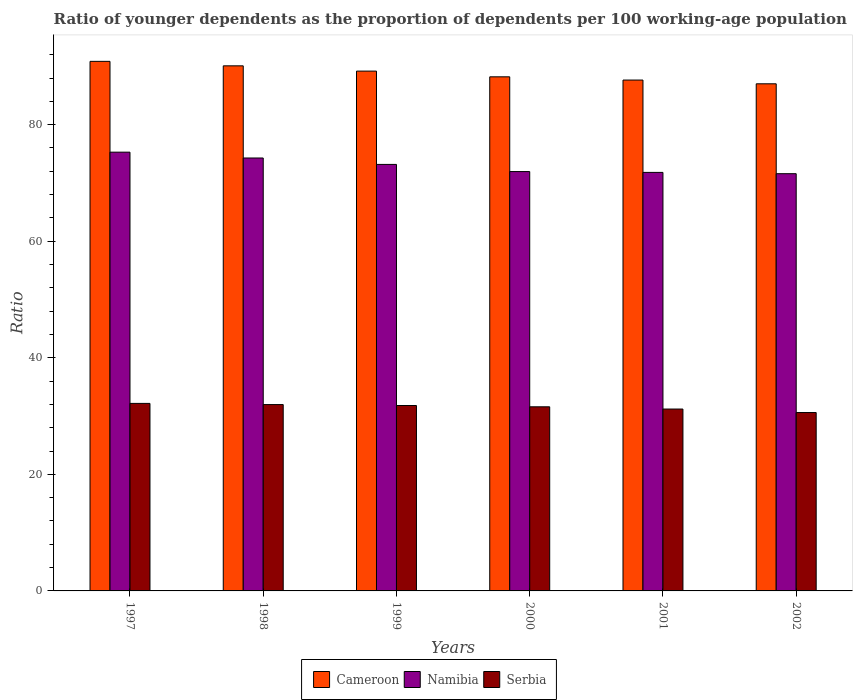How many different coloured bars are there?
Provide a succinct answer. 3. Are the number of bars per tick equal to the number of legend labels?
Your answer should be very brief. Yes. How many bars are there on the 4th tick from the left?
Keep it short and to the point. 3. How many bars are there on the 5th tick from the right?
Provide a succinct answer. 3. In how many cases, is the number of bars for a given year not equal to the number of legend labels?
Your answer should be very brief. 0. What is the age dependency ratio(young) in Cameroon in 2001?
Your answer should be very brief. 87.65. Across all years, what is the maximum age dependency ratio(young) in Namibia?
Offer a terse response. 75.28. Across all years, what is the minimum age dependency ratio(young) in Cameroon?
Make the answer very short. 87. In which year was the age dependency ratio(young) in Namibia minimum?
Your response must be concise. 2002. What is the total age dependency ratio(young) in Serbia in the graph?
Keep it short and to the point. 189.35. What is the difference between the age dependency ratio(young) in Serbia in 1999 and that in 2000?
Your answer should be very brief. 0.22. What is the difference between the age dependency ratio(young) in Namibia in 1998 and the age dependency ratio(young) in Serbia in 1999?
Provide a short and direct response. 42.47. What is the average age dependency ratio(young) in Serbia per year?
Offer a terse response. 31.56. In the year 2002, what is the difference between the age dependency ratio(young) in Namibia and age dependency ratio(young) in Cameroon?
Your response must be concise. -15.42. What is the ratio of the age dependency ratio(young) in Serbia in 1998 to that in 2002?
Give a very brief answer. 1.04. Is the age dependency ratio(young) in Cameroon in 2000 less than that in 2002?
Your response must be concise. No. Is the difference between the age dependency ratio(young) in Namibia in 1998 and 2002 greater than the difference between the age dependency ratio(young) in Cameroon in 1998 and 2002?
Provide a succinct answer. No. What is the difference between the highest and the second highest age dependency ratio(young) in Namibia?
Provide a succinct answer. 1. What is the difference between the highest and the lowest age dependency ratio(young) in Namibia?
Provide a short and direct response. 3.69. Is the sum of the age dependency ratio(young) in Serbia in 1998 and 2002 greater than the maximum age dependency ratio(young) in Namibia across all years?
Your answer should be very brief. No. What does the 3rd bar from the left in 2000 represents?
Provide a short and direct response. Serbia. What does the 1st bar from the right in 2002 represents?
Your answer should be very brief. Serbia. Are the values on the major ticks of Y-axis written in scientific E-notation?
Keep it short and to the point. No. Does the graph contain any zero values?
Your answer should be very brief. No. Where does the legend appear in the graph?
Your response must be concise. Bottom center. How are the legend labels stacked?
Offer a very short reply. Horizontal. What is the title of the graph?
Offer a very short reply. Ratio of younger dependents as the proportion of dependents per 100 working-age population. Does "North America" appear as one of the legend labels in the graph?
Offer a very short reply. No. What is the label or title of the Y-axis?
Provide a short and direct response. Ratio. What is the Ratio of Cameroon in 1997?
Keep it short and to the point. 90.86. What is the Ratio of Namibia in 1997?
Offer a very short reply. 75.28. What is the Ratio of Serbia in 1997?
Provide a short and direct response. 32.17. What is the Ratio of Cameroon in 1998?
Your response must be concise. 90.09. What is the Ratio of Namibia in 1998?
Your answer should be compact. 74.28. What is the Ratio in Serbia in 1998?
Your answer should be very brief. 31.97. What is the Ratio in Cameroon in 1999?
Provide a succinct answer. 89.18. What is the Ratio in Namibia in 1999?
Make the answer very short. 73.18. What is the Ratio in Serbia in 1999?
Keep it short and to the point. 31.81. What is the Ratio in Cameroon in 2000?
Keep it short and to the point. 88.2. What is the Ratio of Namibia in 2000?
Offer a very short reply. 71.95. What is the Ratio in Serbia in 2000?
Provide a short and direct response. 31.59. What is the Ratio of Cameroon in 2001?
Keep it short and to the point. 87.65. What is the Ratio of Namibia in 2001?
Your response must be concise. 71.8. What is the Ratio in Serbia in 2001?
Offer a very short reply. 31.2. What is the Ratio of Cameroon in 2002?
Keep it short and to the point. 87. What is the Ratio in Namibia in 2002?
Give a very brief answer. 71.58. What is the Ratio of Serbia in 2002?
Provide a succinct answer. 30.6. Across all years, what is the maximum Ratio of Cameroon?
Offer a very short reply. 90.86. Across all years, what is the maximum Ratio in Namibia?
Your answer should be compact. 75.28. Across all years, what is the maximum Ratio in Serbia?
Ensure brevity in your answer.  32.17. Across all years, what is the minimum Ratio of Cameroon?
Provide a short and direct response. 87. Across all years, what is the minimum Ratio in Namibia?
Make the answer very short. 71.58. Across all years, what is the minimum Ratio in Serbia?
Offer a very short reply. 30.6. What is the total Ratio of Cameroon in the graph?
Give a very brief answer. 532.98. What is the total Ratio of Namibia in the graph?
Your response must be concise. 438.06. What is the total Ratio in Serbia in the graph?
Offer a very short reply. 189.35. What is the difference between the Ratio of Cameroon in 1997 and that in 1998?
Your answer should be compact. 0.77. What is the difference between the Ratio of Serbia in 1997 and that in 1998?
Your response must be concise. 0.2. What is the difference between the Ratio in Cameroon in 1997 and that in 1999?
Ensure brevity in your answer.  1.67. What is the difference between the Ratio in Namibia in 1997 and that in 1999?
Your answer should be compact. 2.1. What is the difference between the Ratio of Serbia in 1997 and that in 1999?
Your answer should be very brief. 0.36. What is the difference between the Ratio in Cameroon in 1997 and that in 2000?
Keep it short and to the point. 2.65. What is the difference between the Ratio in Namibia in 1997 and that in 2000?
Provide a short and direct response. 3.33. What is the difference between the Ratio of Serbia in 1997 and that in 2000?
Give a very brief answer. 0.58. What is the difference between the Ratio of Cameroon in 1997 and that in 2001?
Ensure brevity in your answer.  3.21. What is the difference between the Ratio of Namibia in 1997 and that in 2001?
Your answer should be very brief. 3.47. What is the difference between the Ratio in Serbia in 1997 and that in 2001?
Keep it short and to the point. 0.97. What is the difference between the Ratio in Cameroon in 1997 and that in 2002?
Offer a terse response. 3.85. What is the difference between the Ratio in Namibia in 1997 and that in 2002?
Keep it short and to the point. 3.69. What is the difference between the Ratio in Serbia in 1997 and that in 2002?
Your answer should be compact. 1.57. What is the difference between the Ratio of Cameroon in 1998 and that in 1999?
Your answer should be very brief. 0.9. What is the difference between the Ratio in Namibia in 1998 and that in 1999?
Keep it short and to the point. 1.1. What is the difference between the Ratio of Serbia in 1998 and that in 1999?
Keep it short and to the point. 0.16. What is the difference between the Ratio in Cameroon in 1998 and that in 2000?
Your answer should be compact. 1.89. What is the difference between the Ratio of Namibia in 1998 and that in 2000?
Give a very brief answer. 2.33. What is the difference between the Ratio in Serbia in 1998 and that in 2000?
Provide a short and direct response. 0.38. What is the difference between the Ratio in Cameroon in 1998 and that in 2001?
Give a very brief answer. 2.44. What is the difference between the Ratio of Namibia in 1998 and that in 2001?
Your response must be concise. 2.47. What is the difference between the Ratio of Serbia in 1998 and that in 2001?
Ensure brevity in your answer.  0.77. What is the difference between the Ratio of Cameroon in 1998 and that in 2002?
Give a very brief answer. 3.08. What is the difference between the Ratio of Namibia in 1998 and that in 2002?
Ensure brevity in your answer.  2.69. What is the difference between the Ratio of Serbia in 1998 and that in 2002?
Your answer should be compact. 1.37. What is the difference between the Ratio in Cameroon in 1999 and that in 2000?
Provide a succinct answer. 0.98. What is the difference between the Ratio in Namibia in 1999 and that in 2000?
Provide a short and direct response. 1.23. What is the difference between the Ratio in Serbia in 1999 and that in 2000?
Provide a short and direct response. 0.22. What is the difference between the Ratio in Cameroon in 1999 and that in 2001?
Offer a terse response. 1.54. What is the difference between the Ratio of Namibia in 1999 and that in 2001?
Your response must be concise. 1.37. What is the difference between the Ratio of Serbia in 1999 and that in 2001?
Your response must be concise. 0.61. What is the difference between the Ratio in Cameroon in 1999 and that in 2002?
Provide a succinct answer. 2.18. What is the difference between the Ratio of Namibia in 1999 and that in 2002?
Offer a terse response. 1.59. What is the difference between the Ratio in Serbia in 1999 and that in 2002?
Provide a short and direct response. 1.21. What is the difference between the Ratio in Cameroon in 2000 and that in 2001?
Offer a very short reply. 0.55. What is the difference between the Ratio in Namibia in 2000 and that in 2001?
Make the answer very short. 0.14. What is the difference between the Ratio in Serbia in 2000 and that in 2001?
Provide a short and direct response. 0.38. What is the difference between the Ratio of Cameroon in 2000 and that in 2002?
Offer a very short reply. 1.2. What is the difference between the Ratio in Namibia in 2000 and that in 2002?
Offer a terse response. 0.36. What is the difference between the Ratio in Serbia in 2000 and that in 2002?
Keep it short and to the point. 0.98. What is the difference between the Ratio in Cameroon in 2001 and that in 2002?
Provide a succinct answer. 0.64. What is the difference between the Ratio of Namibia in 2001 and that in 2002?
Ensure brevity in your answer.  0.22. What is the difference between the Ratio in Serbia in 2001 and that in 2002?
Keep it short and to the point. 0.6. What is the difference between the Ratio in Cameroon in 1997 and the Ratio in Namibia in 1998?
Provide a short and direct response. 16.58. What is the difference between the Ratio of Cameroon in 1997 and the Ratio of Serbia in 1998?
Ensure brevity in your answer.  58.88. What is the difference between the Ratio in Namibia in 1997 and the Ratio in Serbia in 1998?
Offer a terse response. 43.3. What is the difference between the Ratio of Cameroon in 1997 and the Ratio of Namibia in 1999?
Give a very brief answer. 17.68. What is the difference between the Ratio in Cameroon in 1997 and the Ratio in Serbia in 1999?
Provide a succinct answer. 59.05. What is the difference between the Ratio in Namibia in 1997 and the Ratio in Serbia in 1999?
Give a very brief answer. 43.47. What is the difference between the Ratio in Cameroon in 1997 and the Ratio in Namibia in 2000?
Keep it short and to the point. 18.91. What is the difference between the Ratio in Cameroon in 1997 and the Ratio in Serbia in 2000?
Keep it short and to the point. 59.27. What is the difference between the Ratio in Namibia in 1997 and the Ratio in Serbia in 2000?
Your response must be concise. 43.69. What is the difference between the Ratio of Cameroon in 1997 and the Ratio of Namibia in 2001?
Make the answer very short. 19.05. What is the difference between the Ratio of Cameroon in 1997 and the Ratio of Serbia in 2001?
Your answer should be very brief. 59.65. What is the difference between the Ratio of Namibia in 1997 and the Ratio of Serbia in 2001?
Offer a very short reply. 44.07. What is the difference between the Ratio of Cameroon in 1997 and the Ratio of Namibia in 2002?
Offer a very short reply. 19.27. What is the difference between the Ratio in Cameroon in 1997 and the Ratio in Serbia in 2002?
Your answer should be compact. 60.25. What is the difference between the Ratio in Namibia in 1997 and the Ratio in Serbia in 2002?
Keep it short and to the point. 44.67. What is the difference between the Ratio of Cameroon in 1998 and the Ratio of Namibia in 1999?
Your answer should be very brief. 16.91. What is the difference between the Ratio in Cameroon in 1998 and the Ratio in Serbia in 1999?
Provide a succinct answer. 58.28. What is the difference between the Ratio in Namibia in 1998 and the Ratio in Serbia in 1999?
Offer a terse response. 42.47. What is the difference between the Ratio in Cameroon in 1998 and the Ratio in Namibia in 2000?
Make the answer very short. 18.14. What is the difference between the Ratio of Cameroon in 1998 and the Ratio of Serbia in 2000?
Ensure brevity in your answer.  58.5. What is the difference between the Ratio in Namibia in 1998 and the Ratio in Serbia in 2000?
Give a very brief answer. 42.69. What is the difference between the Ratio of Cameroon in 1998 and the Ratio of Namibia in 2001?
Provide a short and direct response. 18.28. What is the difference between the Ratio in Cameroon in 1998 and the Ratio in Serbia in 2001?
Make the answer very short. 58.88. What is the difference between the Ratio of Namibia in 1998 and the Ratio of Serbia in 2001?
Your answer should be very brief. 43.07. What is the difference between the Ratio in Cameroon in 1998 and the Ratio in Namibia in 2002?
Your answer should be compact. 18.5. What is the difference between the Ratio in Cameroon in 1998 and the Ratio in Serbia in 2002?
Give a very brief answer. 59.48. What is the difference between the Ratio of Namibia in 1998 and the Ratio of Serbia in 2002?
Make the answer very short. 43.67. What is the difference between the Ratio in Cameroon in 1999 and the Ratio in Namibia in 2000?
Your answer should be very brief. 17.24. What is the difference between the Ratio in Cameroon in 1999 and the Ratio in Serbia in 2000?
Your answer should be compact. 57.59. What is the difference between the Ratio in Namibia in 1999 and the Ratio in Serbia in 2000?
Provide a succinct answer. 41.59. What is the difference between the Ratio in Cameroon in 1999 and the Ratio in Namibia in 2001?
Your answer should be compact. 17.38. What is the difference between the Ratio in Cameroon in 1999 and the Ratio in Serbia in 2001?
Offer a terse response. 57.98. What is the difference between the Ratio in Namibia in 1999 and the Ratio in Serbia in 2001?
Your answer should be very brief. 41.97. What is the difference between the Ratio of Cameroon in 1999 and the Ratio of Namibia in 2002?
Offer a terse response. 17.6. What is the difference between the Ratio in Cameroon in 1999 and the Ratio in Serbia in 2002?
Your answer should be very brief. 58.58. What is the difference between the Ratio of Namibia in 1999 and the Ratio of Serbia in 2002?
Give a very brief answer. 42.57. What is the difference between the Ratio of Cameroon in 2000 and the Ratio of Namibia in 2001?
Provide a succinct answer. 16.4. What is the difference between the Ratio in Cameroon in 2000 and the Ratio in Serbia in 2001?
Keep it short and to the point. 57. What is the difference between the Ratio in Namibia in 2000 and the Ratio in Serbia in 2001?
Your response must be concise. 40.74. What is the difference between the Ratio of Cameroon in 2000 and the Ratio of Namibia in 2002?
Offer a terse response. 16.62. What is the difference between the Ratio in Cameroon in 2000 and the Ratio in Serbia in 2002?
Ensure brevity in your answer.  57.6. What is the difference between the Ratio of Namibia in 2000 and the Ratio of Serbia in 2002?
Your answer should be compact. 41.34. What is the difference between the Ratio of Cameroon in 2001 and the Ratio of Namibia in 2002?
Keep it short and to the point. 16.06. What is the difference between the Ratio in Cameroon in 2001 and the Ratio in Serbia in 2002?
Provide a succinct answer. 57.04. What is the difference between the Ratio of Namibia in 2001 and the Ratio of Serbia in 2002?
Make the answer very short. 41.2. What is the average Ratio of Cameroon per year?
Offer a terse response. 88.83. What is the average Ratio in Namibia per year?
Ensure brevity in your answer.  73.01. What is the average Ratio in Serbia per year?
Keep it short and to the point. 31.56. In the year 1997, what is the difference between the Ratio of Cameroon and Ratio of Namibia?
Offer a very short reply. 15.58. In the year 1997, what is the difference between the Ratio of Cameroon and Ratio of Serbia?
Your response must be concise. 58.68. In the year 1997, what is the difference between the Ratio of Namibia and Ratio of Serbia?
Provide a succinct answer. 43.1. In the year 1998, what is the difference between the Ratio of Cameroon and Ratio of Namibia?
Ensure brevity in your answer.  15.81. In the year 1998, what is the difference between the Ratio in Cameroon and Ratio in Serbia?
Ensure brevity in your answer.  58.12. In the year 1998, what is the difference between the Ratio in Namibia and Ratio in Serbia?
Provide a succinct answer. 42.3. In the year 1999, what is the difference between the Ratio of Cameroon and Ratio of Namibia?
Offer a very short reply. 16.01. In the year 1999, what is the difference between the Ratio of Cameroon and Ratio of Serbia?
Your answer should be compact. 57.37. In the year 1999, what is the difference between the Ratio in Namibia and Ratio in Serbia?
Offer a terse response. 41.37. In the year 2000, what is the difference between the Ratio in Cameroon and Ratio in Namibia?
Offer a terse response. 16.26. In the year 2000, what is the difference between the Ratio of Cameroon and Ratio of Serbia?
Your answer should be compact. 56.61. In the year 2000, what is the difference between the Ratio of Namibia and Ratio of Serbia?
Ensure brevity in your answer.  40.36. In the year 2001, what is the difference between the Ratio of Cameroon and Ratio of Namibia?
Your answer should be compact. 15.84. In the year 2001, what is the difference between the Ratio in Cameroon and Ratio in Serbia?
Keep it short and to the point. 56.44. In the year 2001, what is the difference between the Ratio of Namibia and Ratio of Serbia?
Your answer should be very brief. 40.6. In the year 2002, what is the difference between the Ratio in Cameroon and Ratio in Namibia?
Offer a very short reply. 15.42. In the year 2002, what is the difference between the Ratio of Cameroon and Ratio of Serbia?
Offer a very short reply. 56.4. In the year 2002, what is the difference between the Ratio of Namibia and Ratio of Serbia?
Provide a succinct answer. 40.98. What is the ratio of the Ratio in Cameroon in 1997 to that in 1998?
Make the answer very short. 1.01. What is the ratio of the Ratio in Namibia in 1997 to that in 1998?
Give a very brief answer. 1.01. What is the ratio of the Ratio in Cameroon in 1997 to that in 1999?
Provide a short and direct response. 1.02. What is the ratio of the Ratio in Namibia in 1997 to that in 1999?
Keep it short and to the point. 1.03. What is the ratio of the Ratio in Serbia in 1997 to that in 1999?
Offer a very short reply. 1.01. What is the ratio of the Ratio of Cameroon in 1997 to that in 2000?
Keep it short and to the point. 1.03. What is the ratio of the Ratio in Namibia in 1997 to that in 2000?
Ensure brevity in your answer.  1.05. What is the ratio of the Ratio in Serbia in 1997 to that in 2000?
Keep it short and to the point. 1.02. What is the ratio of the Ratio in Cameroon in 1997 to that in 2001?
Your answer should be compact. 1.04. What is the ratio of the Ratio in Namibia in 1997 to that in 2001?
Provide a succinct answer. 1.05. What is the ratio of the Ratio of Serbia in 1997 to that in 2001?
Your answer should be very brief. 1.03. What is the ratio of the Ratio of Cameroon in 1997 to that in 2002?
Your answer should be compact. 1.04. What is the ratio of the Ratio in Namibia in 1997 to that in 2002?
Offer a terse response. 1.05. What is the ratio of the Ratio in Serbia in 1997 to that in 2002?
Your response must be concise. 1.05. What is the ratio of the Ratio in Cameroon in 1998 to that in 1999?
Keep it short and to the point. 1.01. What is the ratio of the Ratio of Namibia in 1998 to that in 1999?
Provide a succinct answer. 1.02. What is the ratio of the Ratio of Cameroon in 1998 to that in 2000?
Your answer should be compact. 1.02. What is the ratio of the Ratio in Namibia in 1998 to that in 2000?
Offer a very short reply. 1.03. What is the ratio of the Ratio of Serbia in 1998 to that in 2000?
Provide a succinct answer. 1.01. What is the ratio of the Ratio in Cameroon in 1998 to that in 2001?
Your answer should be very brief. 1.03. What is the ratio of the Ratio of Namibia in 1998 to that in 2001?
Offer a very short reply. 1.03. What is the ratio of the Ratio in Serbia in 1998 to that in 2001?
Offer a terse response. 1.02. What is the ratio of the Ratio of Cameroon in 1998 to that in 2002?
Give a very brief answer. 1.04. What is the ratio of the Ratio of Namibia in 1998 to that in 2002?
Keep it short and to the point. 1.04. What is the ratio of the Ratio of Serbia in 1998 to that in 2002?
Keep it short and to the point. 1.04. What is the ratio of the Ratio in Cameroon in 1999 to that in 2000?
Ensure brevity in your answer.  1.01. What is the ratio of the Ratio in Namibia in 1999 to that in 2000?
Make the answer very short. 1.02. What is the ratio of the Ratio in Serbia in 1999 to that in 2000?
Keep it short and to the point. 1.01. What is the ratio of the Ratio of Cameroon in 1999 to that in 2001?
Your answer should be compact. 1.02. What is the ratio of the Ratio of Namibia in 1999 to that in 2001?
Provide a succinct answer. 1.02. What is the ratio of the Ratio in Serbia in 1999 to that in 2001?
Provide a succinct answer. 1.02. What is the ratio of the Ratio of Cameroon in 1999 to that in 2002?
Your answer should be compact. 1.02. What is the ratio of the Ratio in Namibia in 1999 to that in 2002?
Make the answer very short. 1.02. What is the ratio of the Ratio in Serbia in 1999 to that in 2002?
Ensure brevity in your answer.  1.04. What is the ratio of the Ratio in Serbia in 2000 to that in 2001?
Offer a terse response. 1.01. What is the ratio of the Ratio in Cameroon in 2000 to that in 2002?
Provide a succinct answer. 1.01. What is the ratio of the Ratio of Serbia in 2000 to that in 2002?
Provide a short and direct response. 1.03. What is the ratio of the Ratio of Cameroon in 2001 to that in 2002?
Ensure brevity in your answer.  1.01. What is the ratio of the Ratio of Serbia in 2001 to that in 2002?
Provide a succinct answer. 1.02. What is the difference between the highest and the second highest Ratio of Cameroon?
Offer a terse response. 0.77. What is the difference between the highest and the second highest Ratio of Namibia?
Your answer should be compact. 1. What is the difference between the highest and the second highest Ratio in Serbia?
Provide a succinct answer. 0.2. What is the difference between the highest and the lowest Ratio of Cameroon?
Your response must be concise. 3.85. What is the difference between the highest and the lowest Ratio of Namibia?
Keep it short and to the point. 3.69. What is the difference between the highest and the lowest Ratio of Serbia?
Make the answer very short. 1.57. 